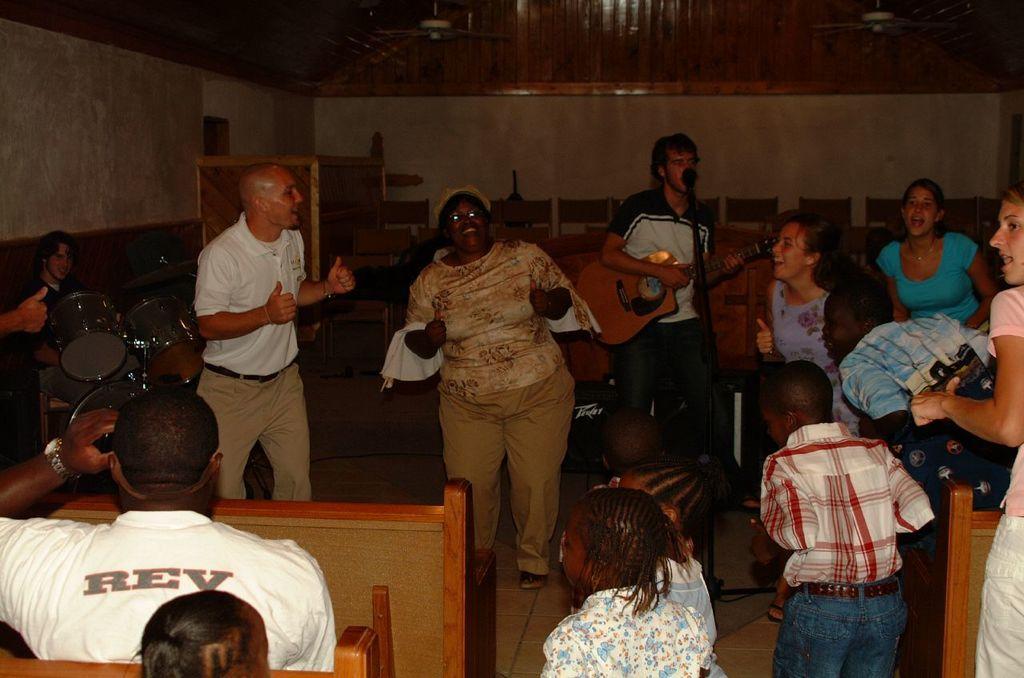Describe this image in one or two sentences. Its inside a room,there are few people dancing and there is a man singing song in the mic and holding a guitar and over left side there is man playing drum and there are few kids in the front and guy guy sat on a wooden sofa. 